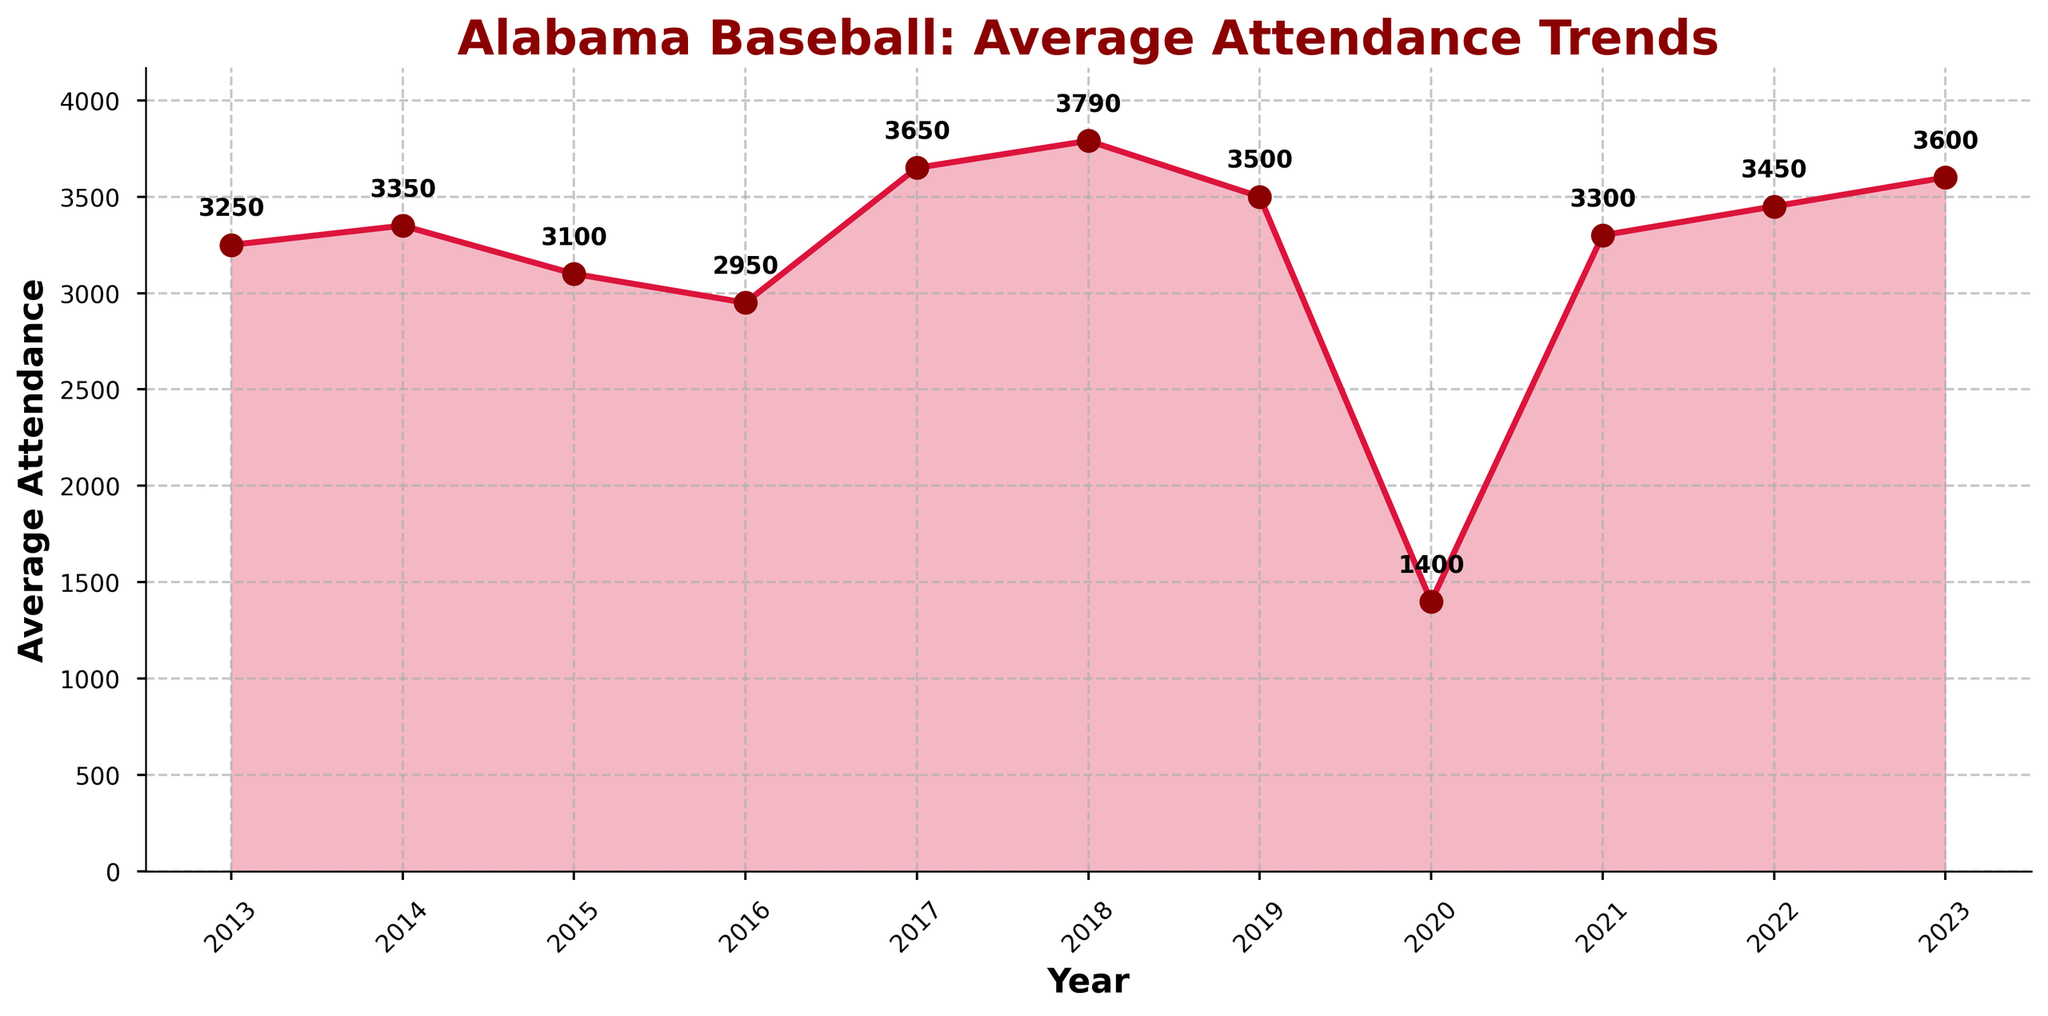What is the title of the plot? The title is displayed at the top of the plot in bold. It provides a summary of what the plot is about.
Answer: Alabama Baseball: Average Attendance Trends Over which years does the time series plot extend? The years are displayed along the x-axis, showing the range of the data points included in the time series plot. The years specified range from 2013 to 2023.
Answer: 2013 to 2023 What is the average attendance in 2020? The plot includes an annotated data point for each year, which includes the specific number for that year. The annotation for 2020 shows the number 1400.
Answer: 1400 Which year had the highest average attendance? By examining the peaks of the plot, the year with the maximum attendance can be identified. The year 2018 shows the highest peak with an annotated value of 3790.
Answer: 2018 What was the trend in attendance from 2019 to 2020? Observing the plot from 2019 to 2020 shows a sharp decline in the line, indicating a significant drop in attendance. The annotation confirms this drop from 3500 in 2019 to 1400 in 2020.
Answer: Significant decrease Calculate the average attendance between 2015 and 2017 inclusive. To find the average, add the attendance figures for 2015 (3100), 2016 (2950), and 2017 (3650) and then divide by the number of years (3). The calculation is (3100 + 2950 + 3650) / 3.
Answer: 3233.33 How does 2023's average attendance compare to the previous year, 2022? By comparing the 2022 value (3450) directly with the 2023 value (3600), it can be determined if there was an increase or decrease. 3600 is higher than 3450, so there was an increase.
Answer: Increased What is the general trend in average attendance from 2013 to 2023? By observing the general slope and movement of the plot from the first to the last data point, a trend can be identified. The plot shows fluctuations but a general increasing trend towards the end.
Answer: Increasing trend Which two consecutive years had the smallest difference in average attendance? By comparing the numerical difference between consecutive years, the smallest difference can be determined. The smallest difference occurs between 2013 (3250) and 2014 (3350), a difference of 100.
Answer: 2013 and 2014 What impact did 2020 have on the overall attendance trend? Observing the plot, 2020 shows a drastic dip down to 1400, breaking the continuity of attendance numbers in other years, indicating an outlier that significantly affects the overall trend.
Answer: Significant drop and outlier 